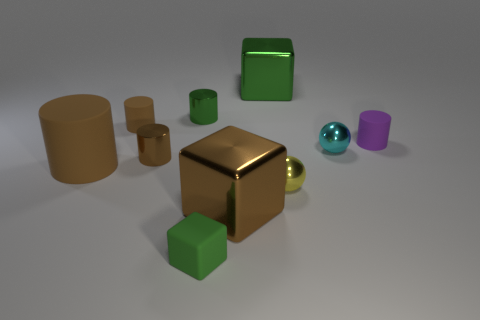Could you estimate the lighting of this scene? The scene appears to be evenly lit with diffused lighting likely from a source above and out of frame, creating soft shadows beneath each object. This type of lighting reduces harsh shadows and helps to evenly reveal the shapes and materials of the objects. 